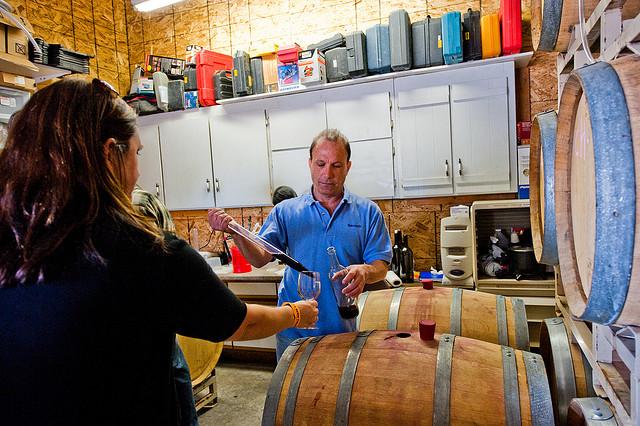What color are the cabinets?
Answer briefly. White. How many people are in the picture?
Quick response, please. 2. What type of beverage is the woman's glass used for?
Quick response, please. Wine. 